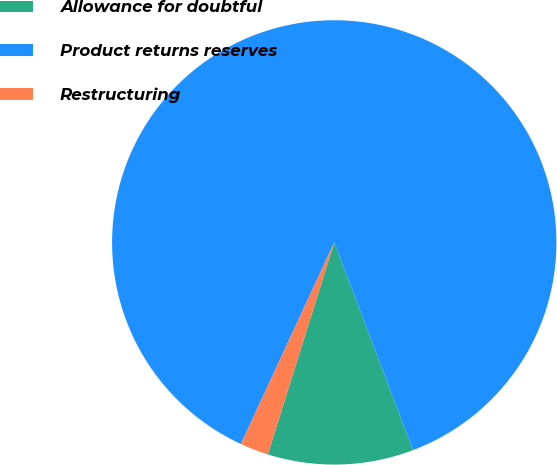Convert chart to OTSL. <chart><loc_0><loc_0><loc_500><loc_500><pie_chart><fcel>Allowance for doubtful<fcel>Product returns reserves<fcel>Restructuring<nl><fcel>10.6%<fcel>87.33%<fcel>2.07%<nl></chart> 